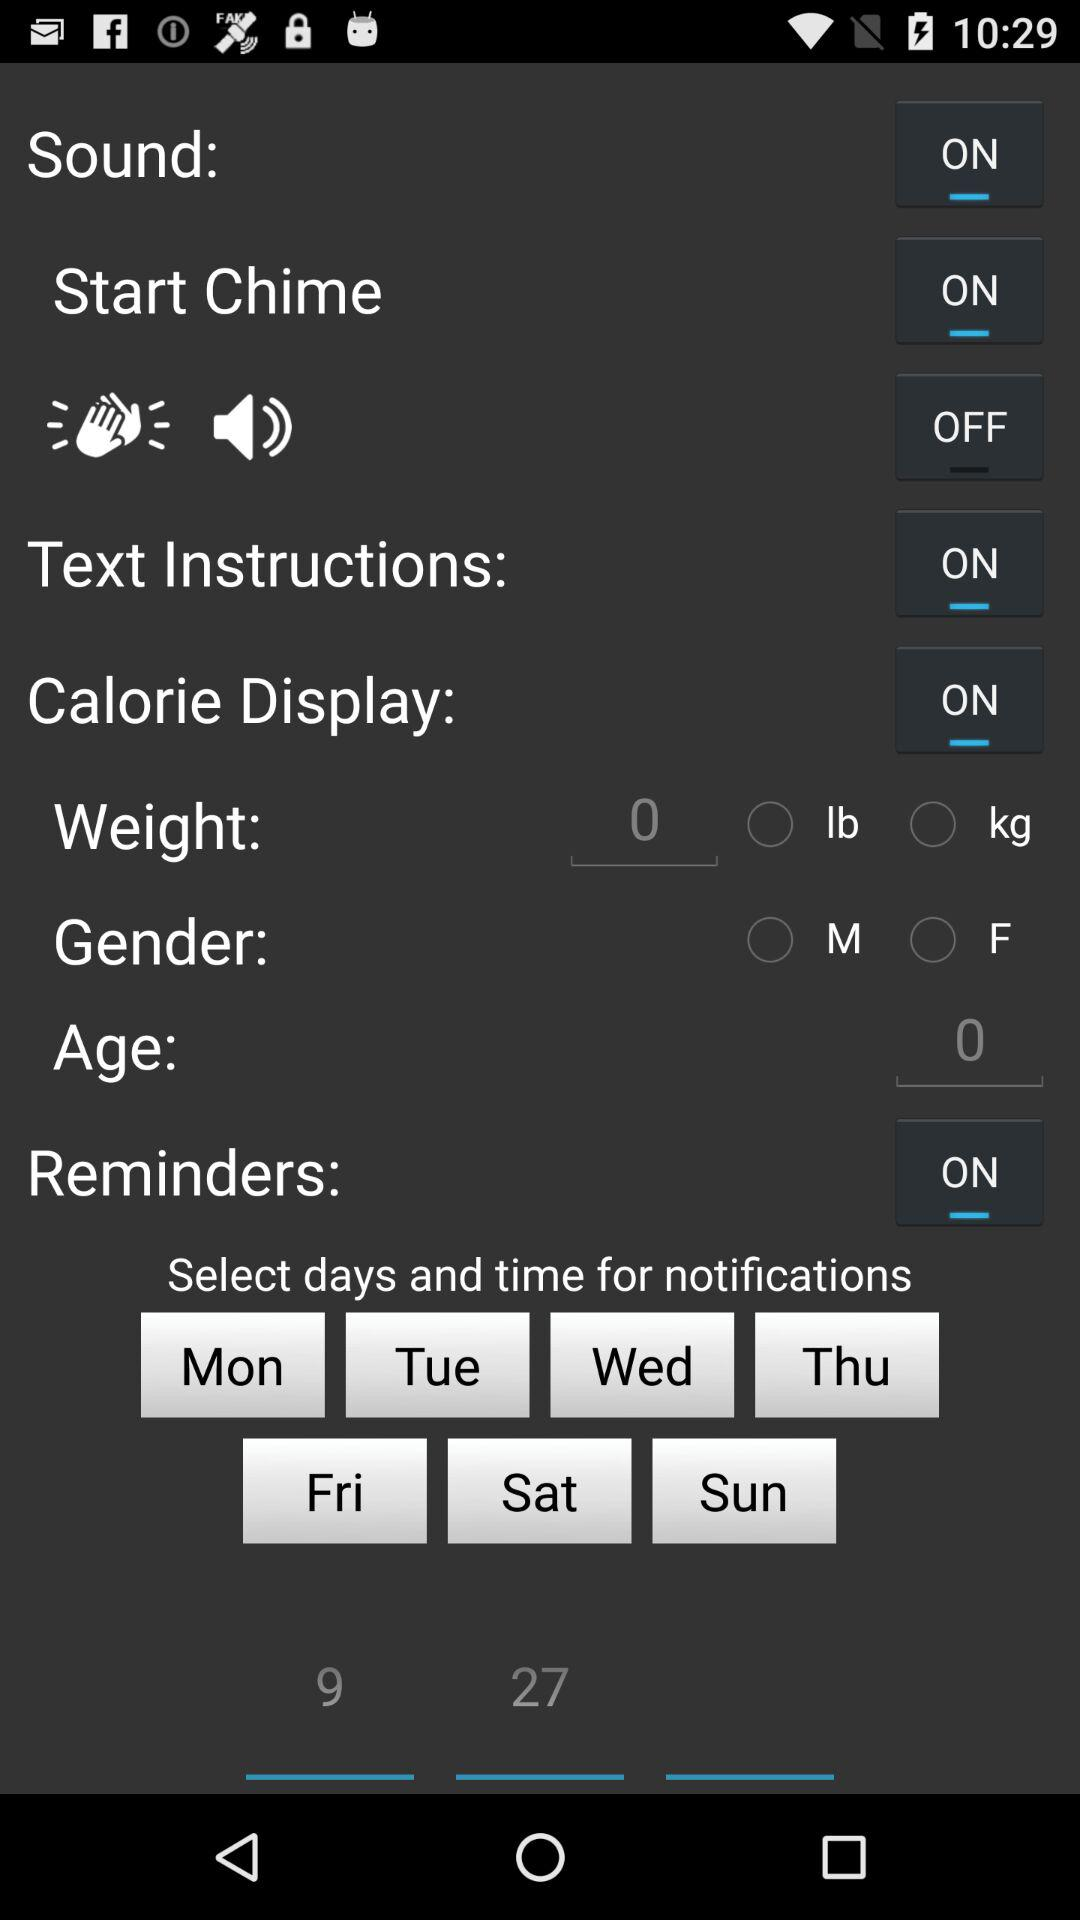What is the age? The age is 0 years. 